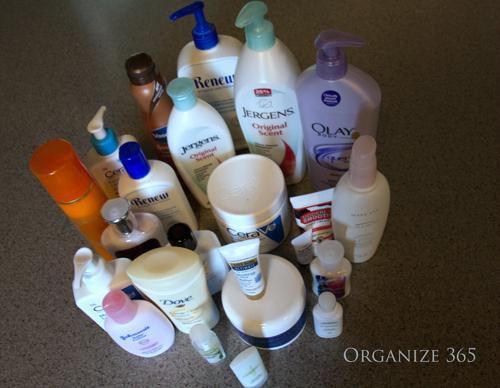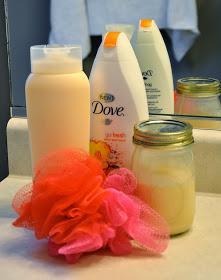The first image is the image on the left, the second image is the image on the right. Considering the images on both sides, is "There are many bathroom items, and not just makeup and lotion." valid? Answer yes or no. Yes. 